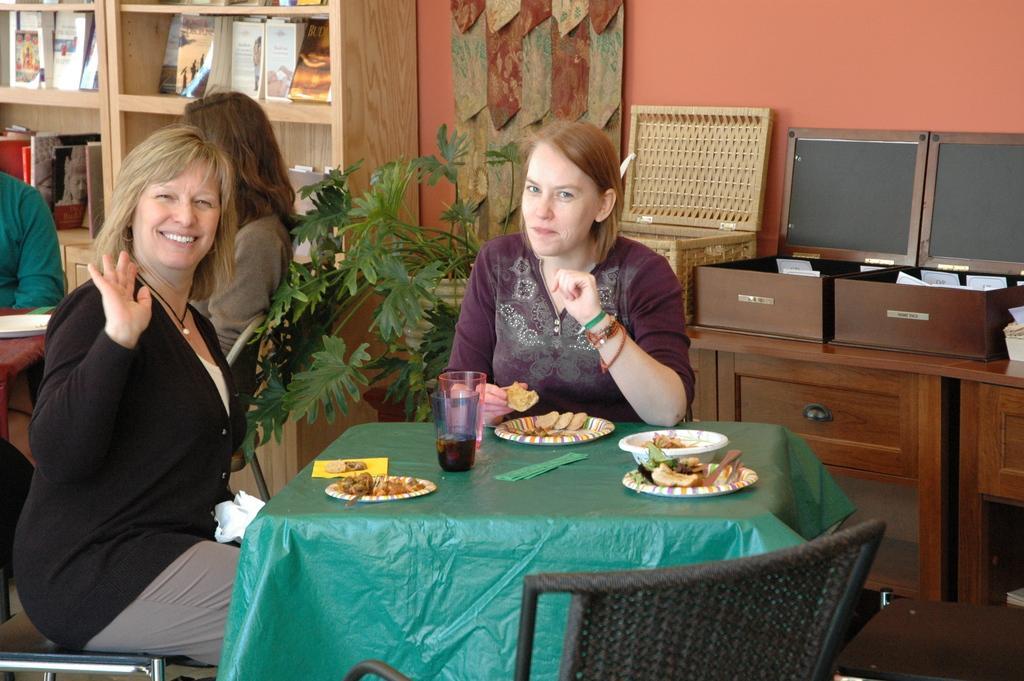How would you summarize this image in a sentence or two? In this picture we can see four persons were in front two women are smiling and in front of them there is a table and on table we can see glasses, plate, bowl, paper and some food in the plate and in the background we can see two persons, racks with books, wall, monitor, boxes, chairs. 